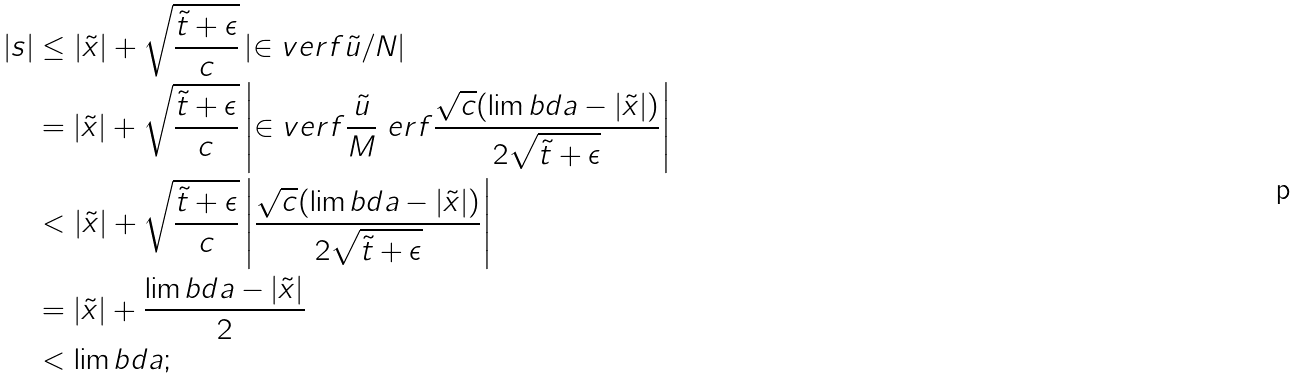<formula> <loc_0><loc_0><loc_500><loc_500>| s | & \leq | \tilde { x } | + \sqrt { \frac { \tilde { t } + \epsilon } c } \left | \in v e r f { \tilde { u } / N } \right | \\ & = | \tilde { x } | + \sqrt { \frac { \tilde { t } + \epsilon } c } \left | \in v e r f { \frac { \tilde { u } } M \ e r f { \frac { \sqrt { c } ( \lim b d a - | \tilde { x } | ) } { 2 \sqrt { \tilde { t } + \epsilon } } } } \right | \\ & < | \tilde { x } | + \sqrt { \frac { \tilde { t } + \epsilon } c } \left | { \frac { \sqrt { c } ( \lim b d a - | \tilde { x } | ) } { 2 \sqrt { \tilde { t } + \epsilon } } } \right | \\ & = | \tilde { x } | + \frac { \lim b d a - | \tilde { x } | } { 2 } \\ & < \lim b d a ;</formula> 